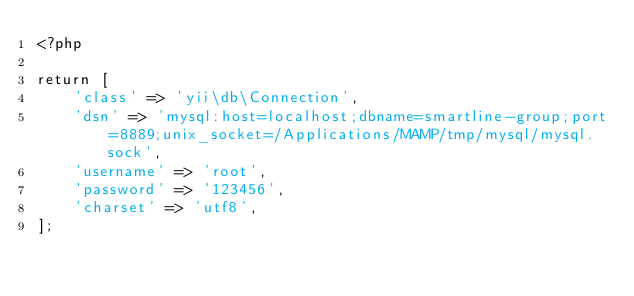<code> <loc_0><loc_0><loc_500><loc_500><_PHP_><?php

return [
    'class' => 'yii\db\Connection',
    'dsn' => 'mysql:host=localhost;dbname=smartline-group;port=8889;unix_socket=/Applications/MAMP/tmp/mysql/mysql.sock',
    'username' => 'root',
    'password' => '123456',
    'charset' => 'utf8',
];
</code> 